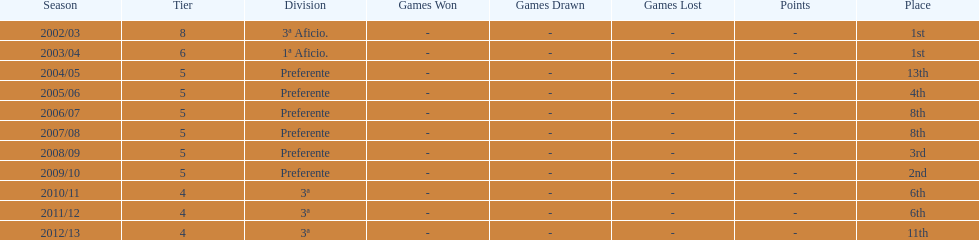What was the number of wins for preferente? 6. 